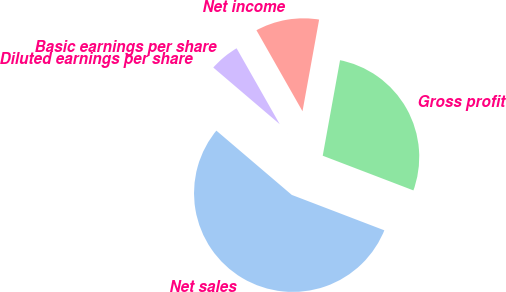Convert chart to OTSL. <chart><loc_0><loc_0><loc_500><loc_500><pie_chart><fcel>Net sales<fcel>Gross profit<fcel>Net income<fcel>Basic earnings per share<fcel>Diluted earnings per share<nl><fcel>55.42%<fcel>27.96%<fcel>11.08%<fcel>5.54%<fcel>0.0%<nl></chart> 